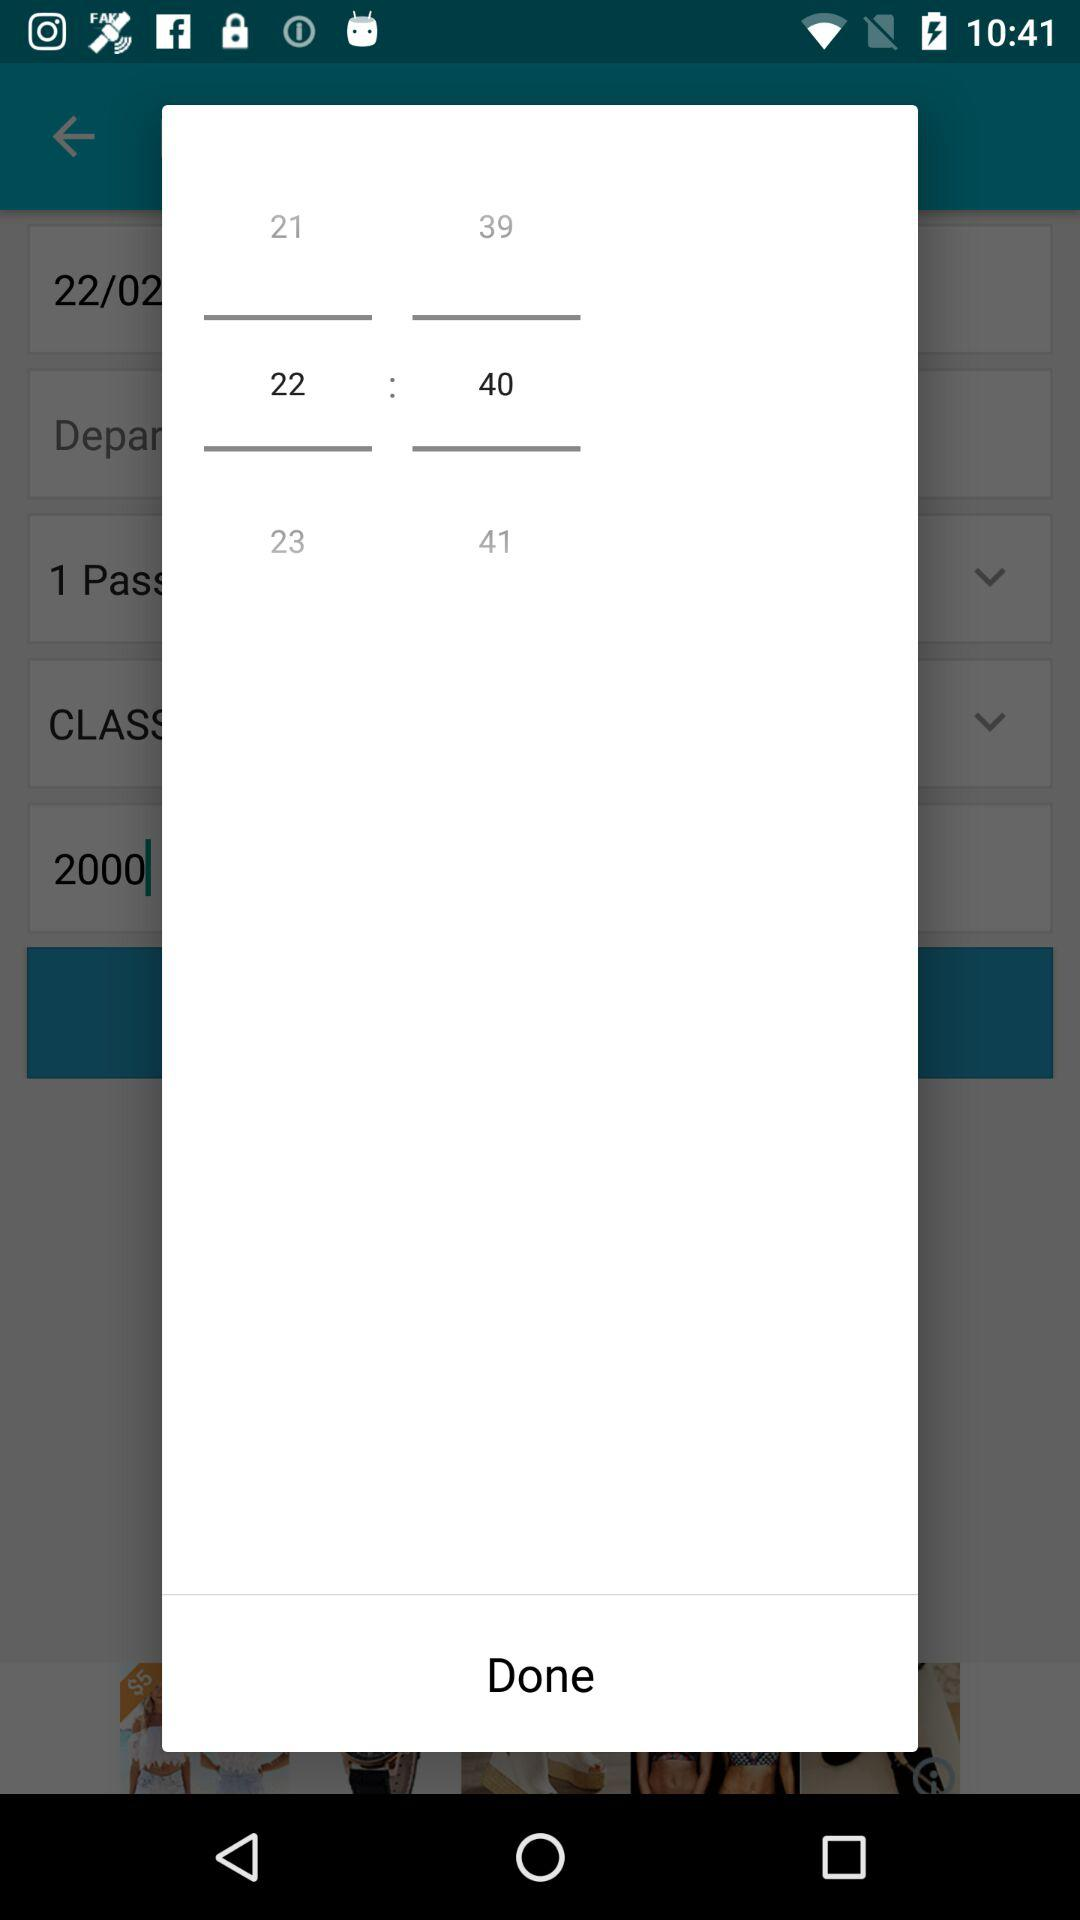Which time is selected on the screen? The selected time on the screen is 22:40. 